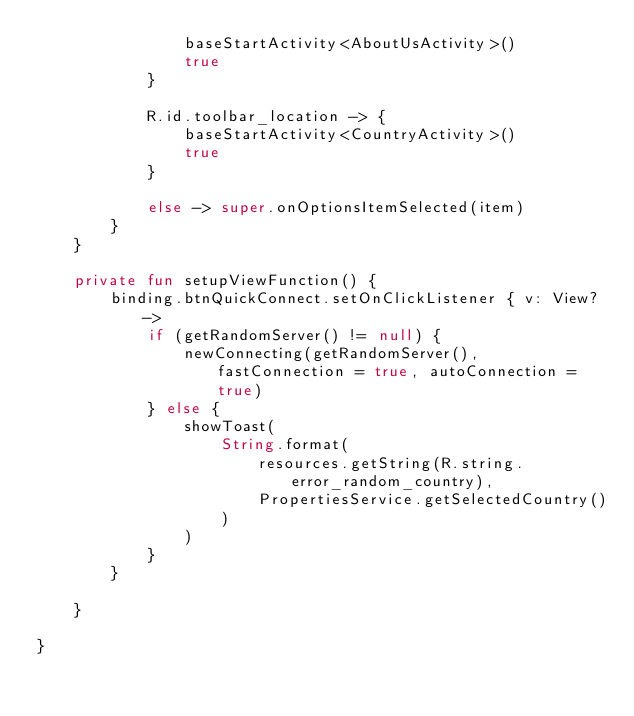<code> <loc_0><loc_0><loc_500><loc_500><_Kotlin_>                baseStartActivity<AboutUsActivity>()
                true
            }

            R.id.toolbar_location -> {
                baseStartActivity<CountryActivity>()
                true
            }

            else -> super.onOptionsItemSelected(item)
        }
    }

    private fun setupViewFunction() {
        binding.btnQuickConnect.setOnClickListener { v: View? ->
            if (getRandomServer() != null) {
                newConnecting(getRandomServer(), fastConnection = true, autoConnection = true)
            } else {
                showToast(
                    String.format(
                        resources.getString(R.string.error_random_country),
                        PropertiesService.getSelectedCountry()
                    )
                )
            }
        }

    }

}</code> 